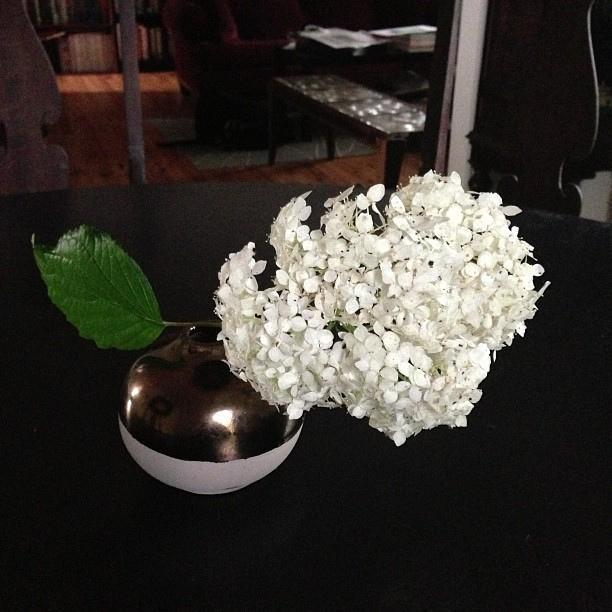How many leafs does this flower have?
Give a very brief answer. 1. How many couches are visible?
Give a very brief answer. 2. How many people are wearing glasses?
Give a very brief answer. 0. 